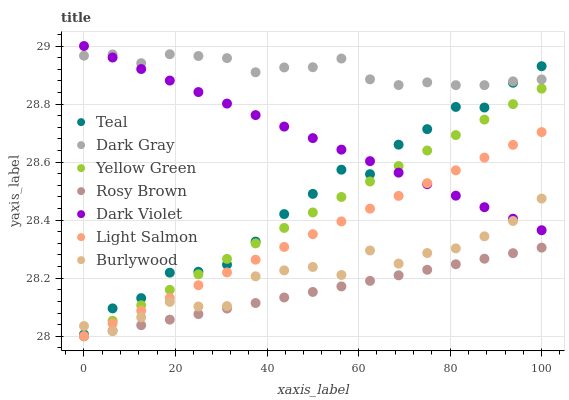Does Rosy Brown have the minimum area under the curve?
Answer yes or no. Yes. Does Dark Gray have the maximum area under the curve?
Answer yes or no. Yes. Does Yellow Green have the minimum area under the curve?
Answer yes or no. No. Does Yellow Green have the maximum area under the curve?
Answer yes or no. No. Is Rosy Brown the smoothest?
Answer yes or no. Yes. Is Teal the roughest?
Answer yes or no. Yes. Is Yellow Green the smoothest?
Answer yes or no. No. Is Yellow Green the roughest?
Answer yes or no. No. Does Light Salmon have the lowest value?
Answer yes or no. Yes. Does Burlywood have the lowest value?
Answer yes or no. No. Does Dark Violet have the highest value?
Answer yes or no. Yes. Does Yellow Green have the highest value?
Answer yes or no. No. Is Light Salmon less than Teal?
Answer yes or no. Yes. Is Dark Violet greater than Rosy Brown?
Answer yes or no. Yes. Does Rosy Brown intersect Yellow Green?
Answer yes or no. Yes. Is Rosy Brown less than Yellow Green?
Answer yes or no. No. Is Rosy Brown greater than Yellow Green?
Answer yes or no. No. Does Light Salmon intersect Teal?
Answer yes or no. No. 